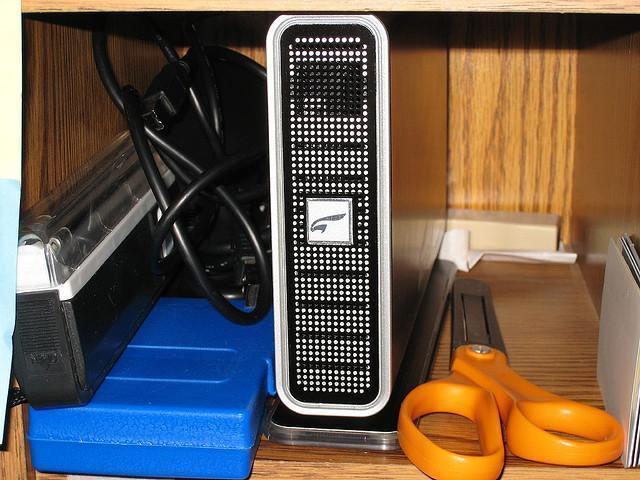How many objects is this person holding?
Give a very brief answer. 0. 